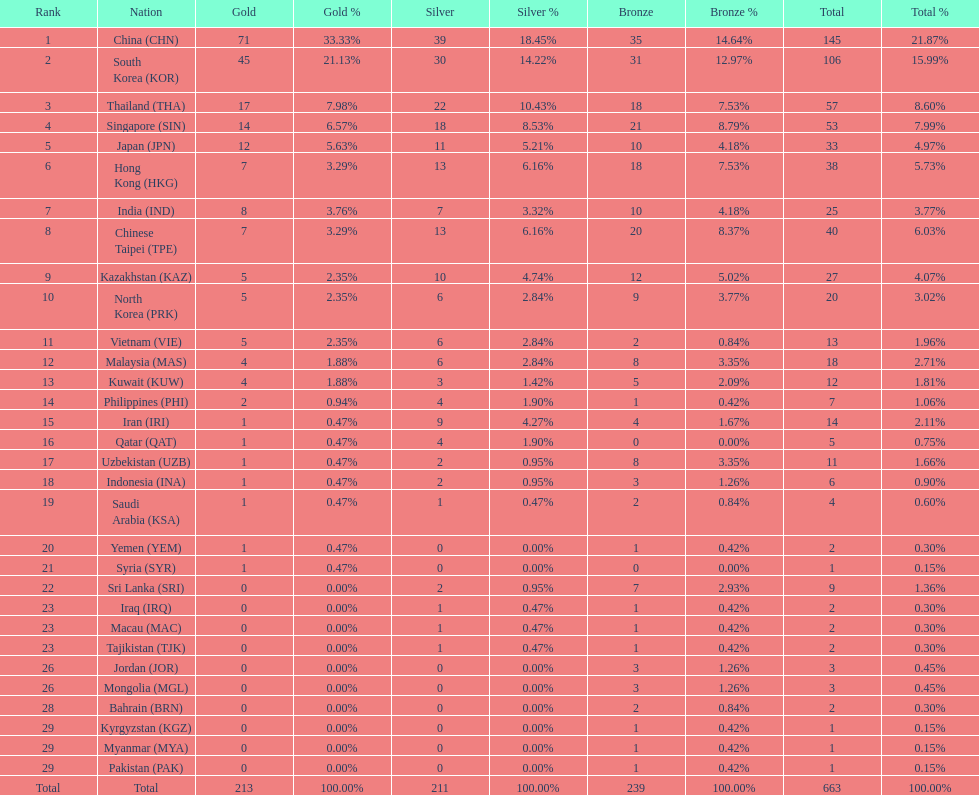Which nation has more gold medals, kuwait or india? India (IND). 